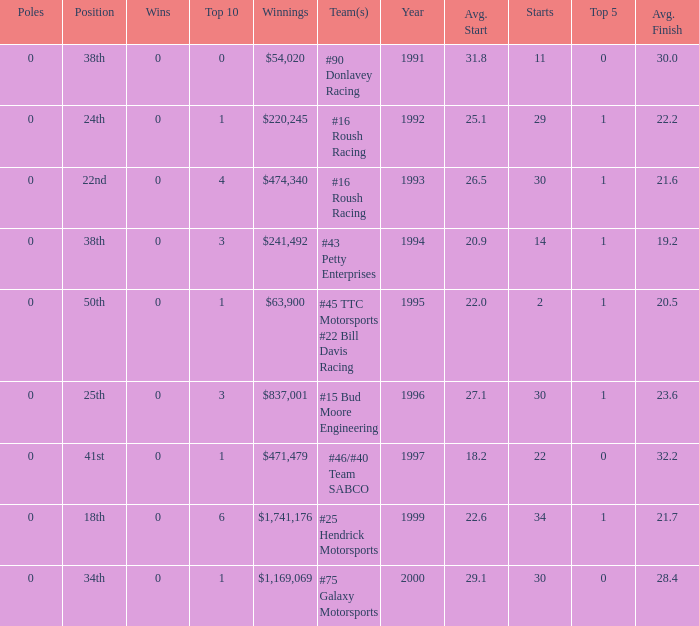I'm looking to parse the entire table for insights. Could you assist me with that? {'header': ['Poles', 'Position', 'Wins', 'Top 10', 'Winnings', 'Team(s)', 'Year', 'Avg. Start', 'Starts', 'Top 5', 'Avg. Finish'], 'rows': [['0', '38th', '0', '0', '$54,020', '#90 Donlavey Racing', '1991', '31.8', '11', '0', '30.0'], ['0', '24th', '0', '1', '$220,245', '#16 Roush Racing', '1992', '25.1', '29', '1', '22.2'], ['0', '22nd', '0', '4', '$474,340', '#16 Roush Racing', '1993', '26.5', '30', '1', '21.6'], ['0', '38th', '0', '3', '$241,492', '#43 Petty Enterprises', '1994', '20.9', '14', '1', '19.2'], ['0', '50th', '0', '1', '$63,900', '#45 TTC Motorsports #22 Bill Davis Racing', '1995', '22.0', '2', '1', '20.5'], ['0', '25th', '0', '3', '$837,001', '#15 Bud Moore Engineering', '1996', '27.1', '30', '1', '23.6'], ['0', '41st', '0', '1', '$471,479', '#46/#40 Team SABCO', '1997', '18.2', '22', '0', '32.2'], ['0', '18th', '0', '6', '$1,741,176', '#25 Hendrick Motorsports', '1999', '22.6', '34', '1', '21.7'], ['0', '34th', '0', '1', '$1,169,069', '#75 Galaxy Motorsports', '2000', '29.1', '30', '0', '28.4']]} What the rank in the top 10 when the  winnings were $1,741,176? 6.0. 